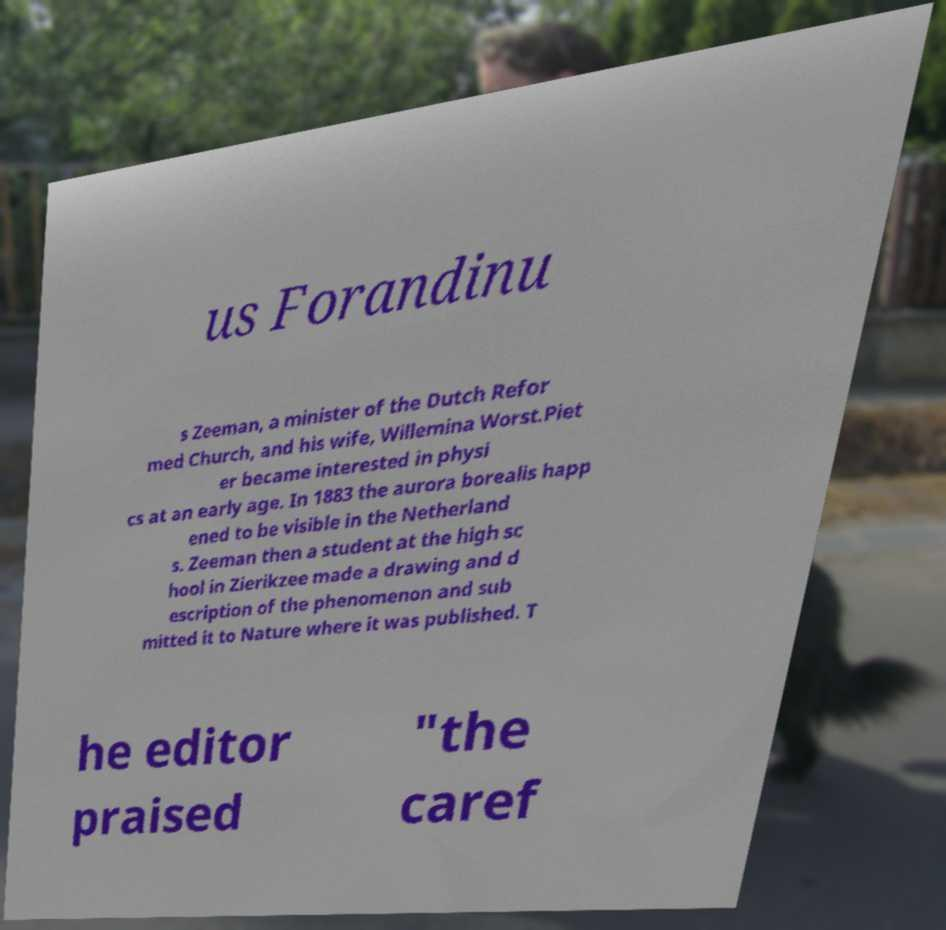Please read and relay the text visible in this image. What does it say? us Forandinu s Zeeman, a minister of the Dutch Refor med Church, and his wife, Willemina Worst.Piet er became interested in physi cs at an early age. In 1883 the aurora borealis happ ened to be visible in the Netherland s. Zeeman then a student at the high sc hool in Zierikzee made a drawing and d escription of the phenomenon and sub mitted it to Nature where it was published. T he editor praised "the caref 